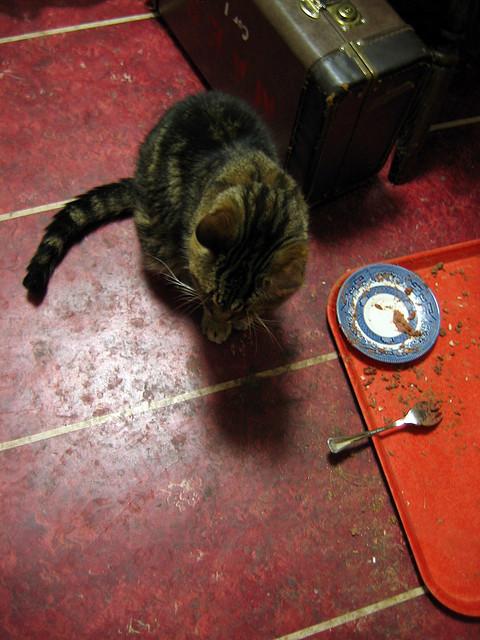What animal is this?
Be succinct. Cat. Is the cat white?
Quick response, please. No. Is the cat eating from the plate?
Give a very brief answer. Yes. 